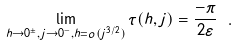Convert formula to latex. <formula><loc_0><loc_0><loc_500><loc_500>\lim _ { h \to 0 ^ { \pm } , j \to 0 ^ { - } , h = o ( j ^ { 3 / 2 } ) } \tau ( h , j ) = \frac { - \pi } { 2 \varepsilon } \ .</formula> 